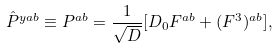Convert formula to latex. <formula><loc_0><loc_0><loc_500><loc_500>\hat { P } ^ { y a b } \equiv P ^ { a b } = \frac { 1 } { \sqrt { D } } [ D _ { 0 } F ^ { a b } + ( F ^ { 3 } ) ^ { a b } ] ,</formula> 